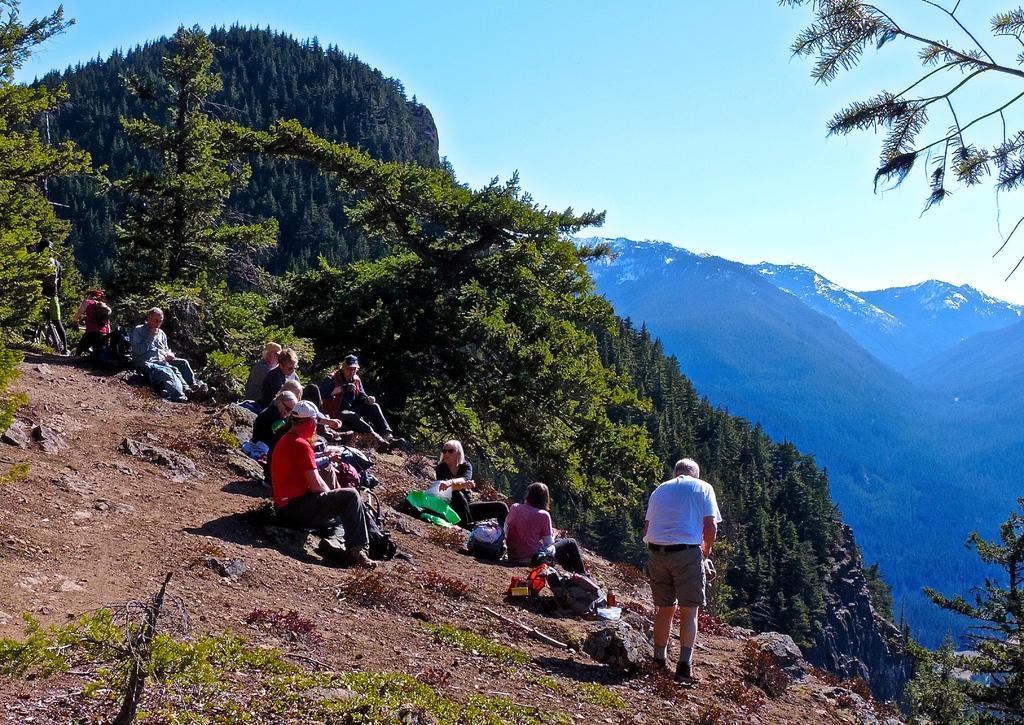How would you summarize this image in a sentence or two? In this image there are people sitting on rock and one man is standing, in the background there are trees and mountains, 